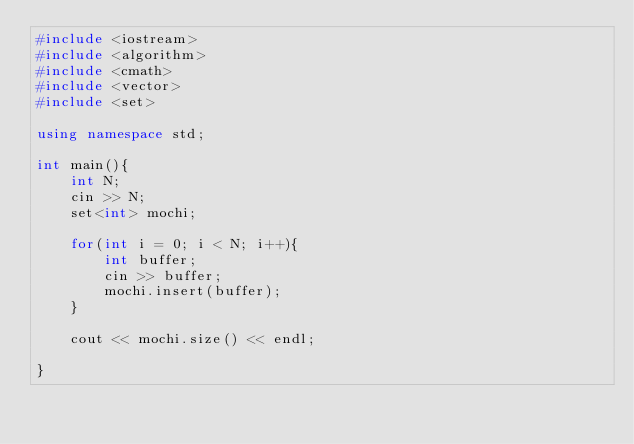Convert code to text. <code><loc_0><loc_0><loc_500><loc_500><_C++_>#include <iostream>
#include <algorithm>
#include <cmath>
#include <vector>
#include <set>

using namespace std;

int main(){
    int N;
    cin >> N;
    set<int> mochi;

    for(int i = 0; i < N; i++){
        int buffer;
        cin >> buffer;
        mochi.insert(buffer);
    }

    cout << mochi.size() << endl;
    
}
</code> 